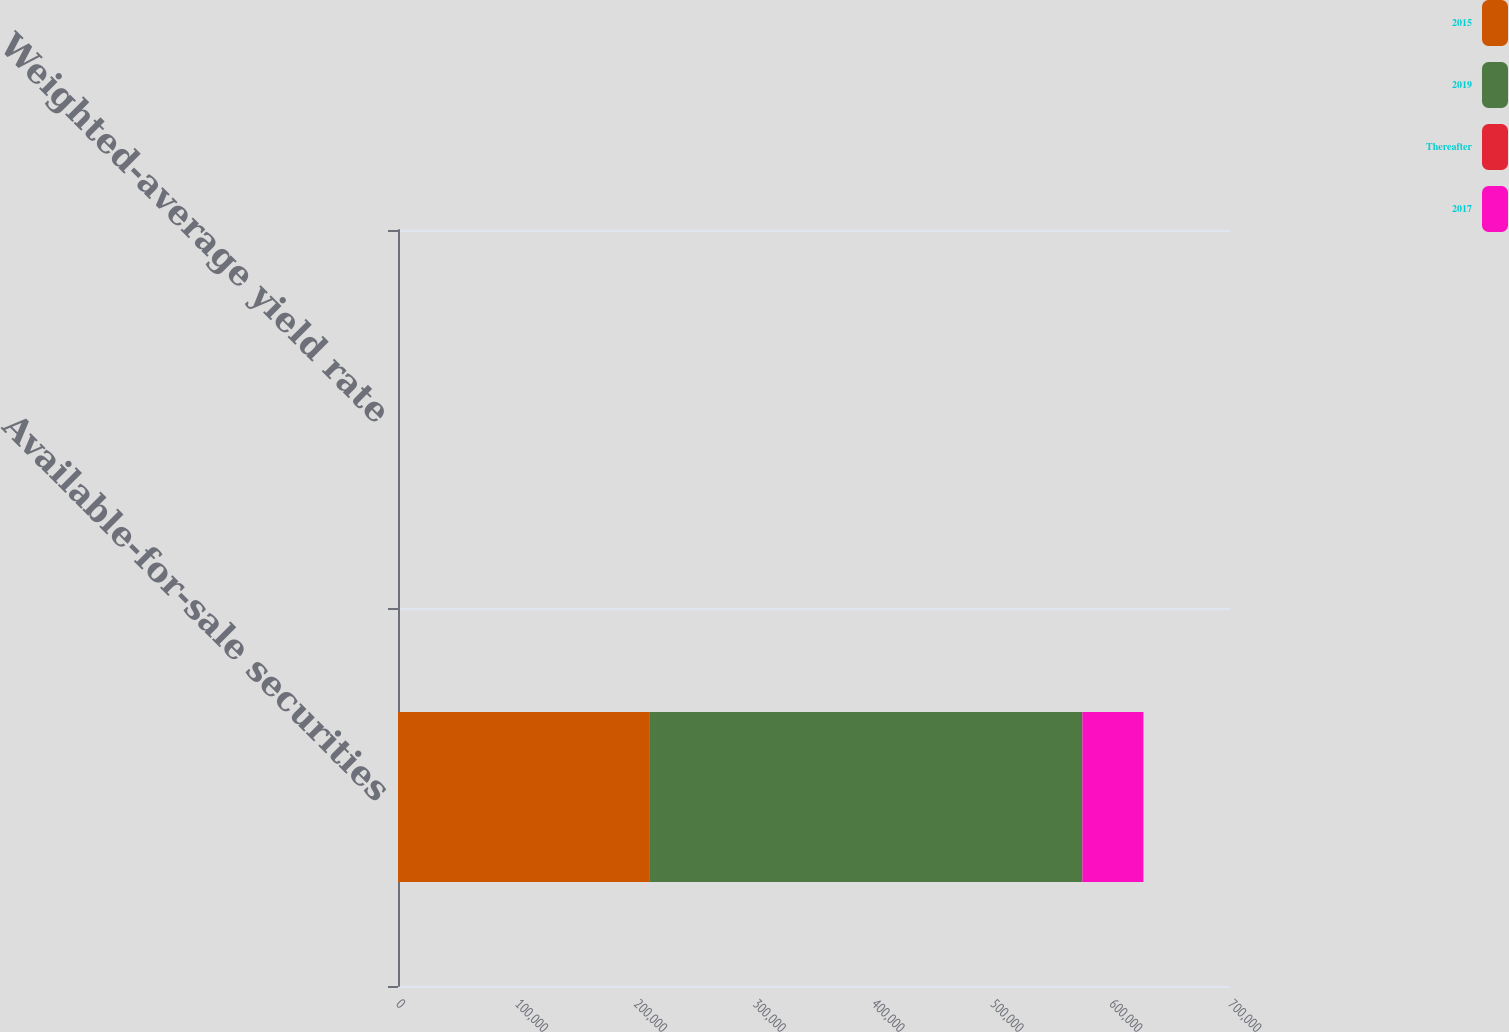Convert chart. <chart><loc_0><loc_0><loc_500><loc_500><stacked_bar_chart><ecel><fcel>Available-for-sale securities<fcel>Weighted-average yield rate<nl><fcel>2015<fcel>211363<fcel>1.41<nl><fcel>2019<fcel>364464<fcel>0.78<nl><fcel>Thereafter<fcel>1.41<fcel>0.95<nl><fcel>2017<fcel>51350<fcel>1.01<nl></chart> 